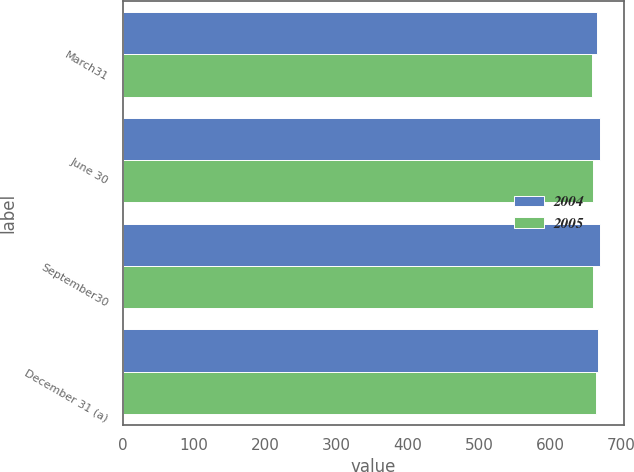Convert chart. <chart><loc_0><loc_0><loc_500><loc_500><stacked_bar_chart><ecel><fcel>March31<fcel>June 30<fcel>September30<fcel>December 31 (a)<nl><fcel>2004<fcel>666<fcel>670<fcel>670<fcel>668<nl><fcel>2005<fcel>659<fcel>661<fcel>661<fcel>664<nl></chart> 